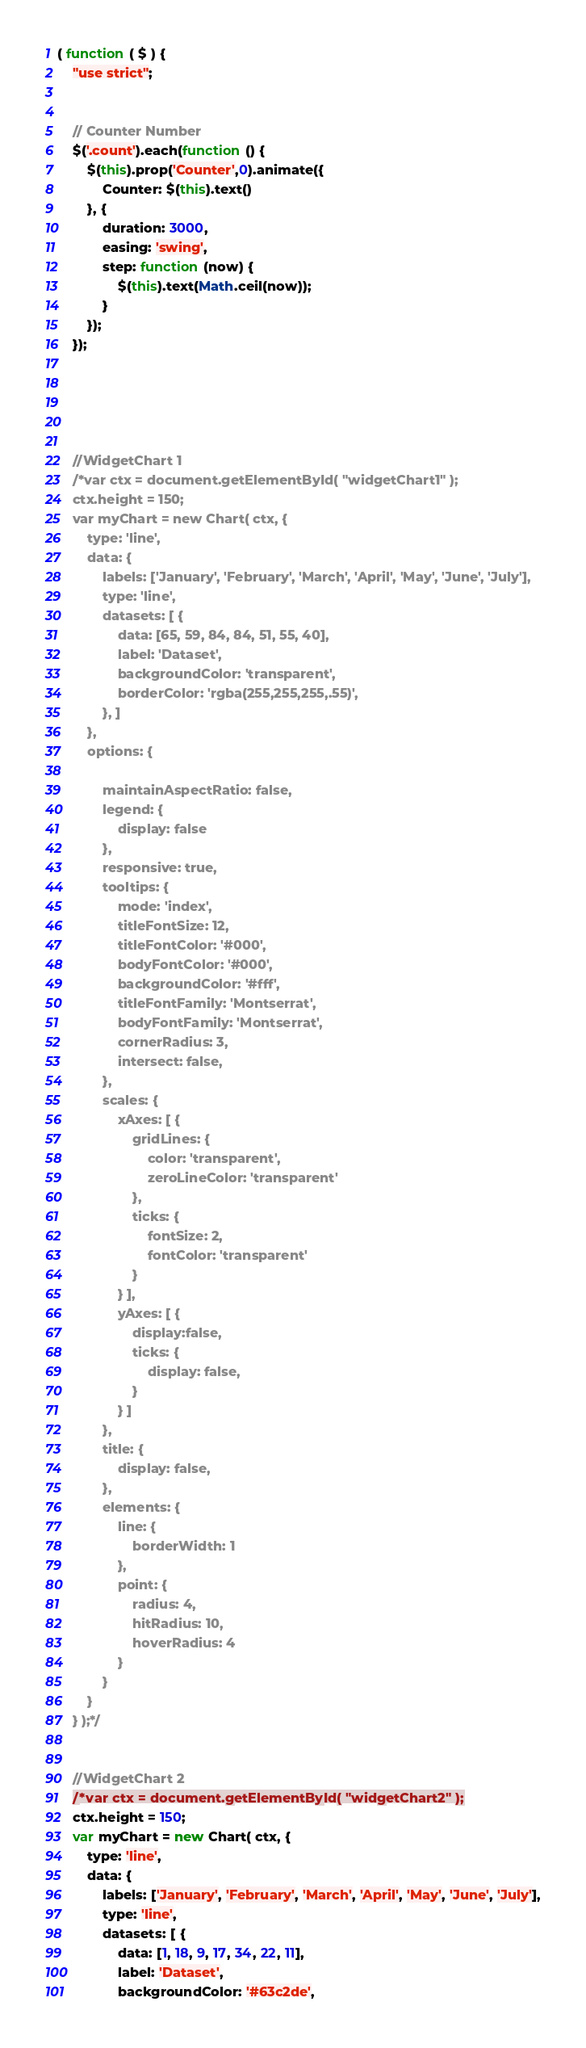Convert code to text. <code><loc_0><loc_0><loc_500><loc_500><_JavaScript_>( function ( $ ) {
    "use strict";


    // Counter Number
    $('.count').each(function () {
        $(this).prop('Counter',0).animate({
            Counter: $(this).text()
        }, {
            duration: 3000,
            easing: 'swing',
            step: function (now) {
                $(this).text(Math.ceil(now));
            }
        });
    });





    //WidgetChart 1
    /*var ctx = document.getElementById( "widgetChart1" );
    ctx.height = 150;
    var myChart = new Chart( ctx, {
        type: 'line',
        data: {
            labels: ['January', 'February', 'March', 'April', 'May', 'June', 'July'],
            type: 'line',
            datasets: [ {
                data: [65, 59, 84, 84, 51, 55, 40],
                label: 'Dataset',
                backgroundColor: 'transparent',
                borderColor: 'rgba(255,255,255,.55)',
            }, ]
        },
        options: {

            maintainAspectRatio: false,
            legend: {
                display: false
            },
            responsive: true,
            tooltips: {
                mode: 'index',
                titleFontSize: 12,
                titleFontColor: '#000',
                bodyFontColor: '#000',
                backgroundColor: '#fff',
                titleFontFamily: 'Montserrat',
                bodyFontFamily: 'Montserrat',
                cornerRadius: 3,
                intersect: false,
            },
            scales: {
                xAxes: [ {
                    gridLines: {
                        color: 'transparent',
                        zeroLineColor: 'transparent'
                    },
                    ticks: {
                        fontSize: 2,
                        fontColor: 'transparent'
                    }
                } ],
                yAxes: [ {
                    display:false,
                    ticks: {
                        display: false,
                    }
                } ]
            },
            title: {
                display: false,
            },
            elements: {
                line: {
                    borderWidth: 1
                },
                point: {
                    radius: 4,
                    hitRadius: 10,
                    hoverRadius: 4
                }
            }
        }
    } );*/


    //WidgetChart 2
    /*var ctx = document.getElementById( "widgetChart2" );
    ctx.height = 150;
    var myChart = new Chart( ctx, {
        type: 'line',
        data: {
            labels: ['January', 'February', 'March', 'April', 'May', 'June', 'July'],
            type: 'line',
            datasets: [ {
                data: [1, 18, 9, 17, 34, 22, 11],
                label: 'Dataset',
                backgroundColor: '#63c2de',</code> 